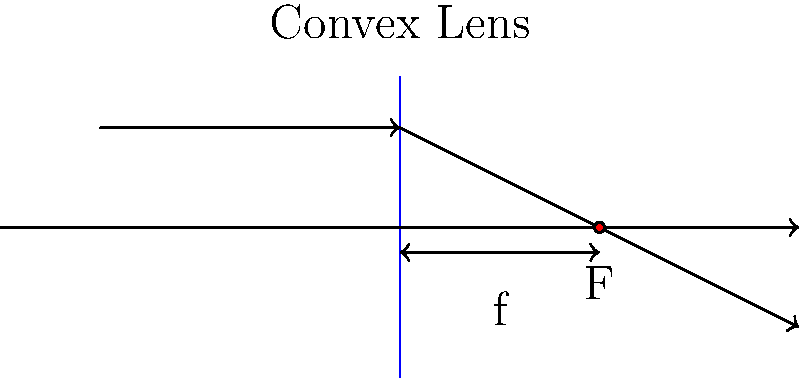As an IT specialist integrating visual content for the e-learning platform, you need to ensure the accuracy of the physics simulations. In the ray diagram shown, a convex lens is represented with an incident ray parallel to the principal axis. If the refracted ray intersects the principal axis at a distance of 40 units from the lens, what is the focal length of the lens? To determine the focal length of a convex lens using a ray diagram, we need to understand the behavior of light rays passing through the lens:

1. A ray parallel to the principal axis will pass through the focal point after refraction.

2. In this diagram, we see an incident ray parallel to the principal axis.

3. The refracted ray intersects the principal axis at a point.

4. This point of intersection is the focal point (F) of the lens.

5. The distance between the lens and the focal point is the focal length (f).

6. From the diagram, we can see that the focal point F is labeled at a distance of 40 units from the lens.

7. Therefore, the focal length of the lens is equal to this distance.

The focal length is a key characteristic of a lens and is crucial for accurately simulating optical systems in the e-learning platform's physics modules.
Answer: 40 units 